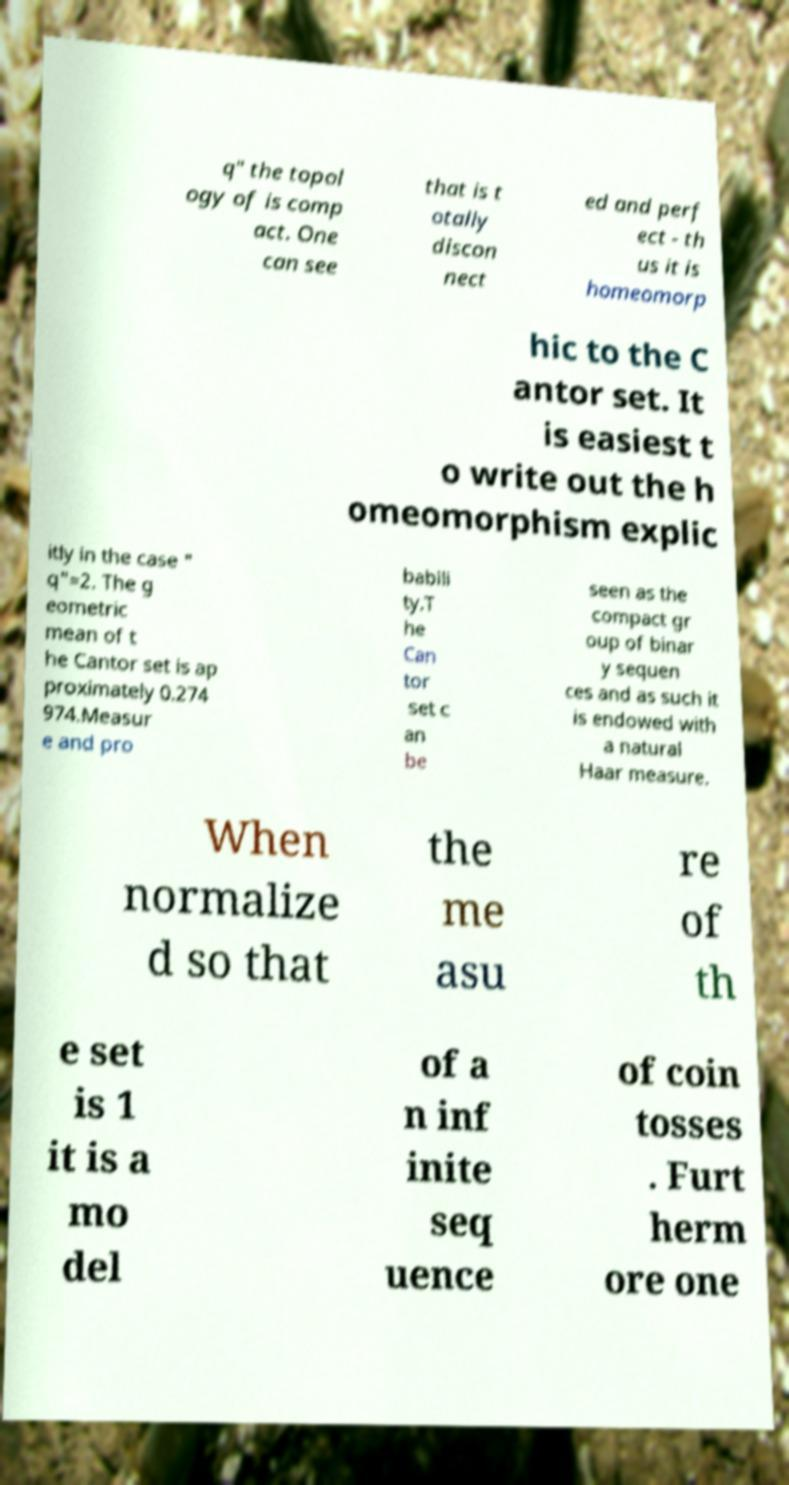Can you read and provide the text displayed in the image?This photo seems to have some interesting text. Can you extract and type it out for me? q" the topol ogy of is comp act. One can see that is t otally discon nect ed and perf ect - th us it is homeomorp hic to the C antor set. It is easiest t o write out the h omeomorphism explic itly in the case " q"=2. The g eometric mean of t he Cantor set is ap proximately 0.274 974.Measur e and pro babili ty.T he Can tor set c an be seen as the compact gr oup of binar y sequen ces and as such it is endowed with a natural Haar measure. When normalize d so that the me asu re of th e set is 1 it is a mo del of a n inf inite seq uence of coin tosses . Furt herm ore one 